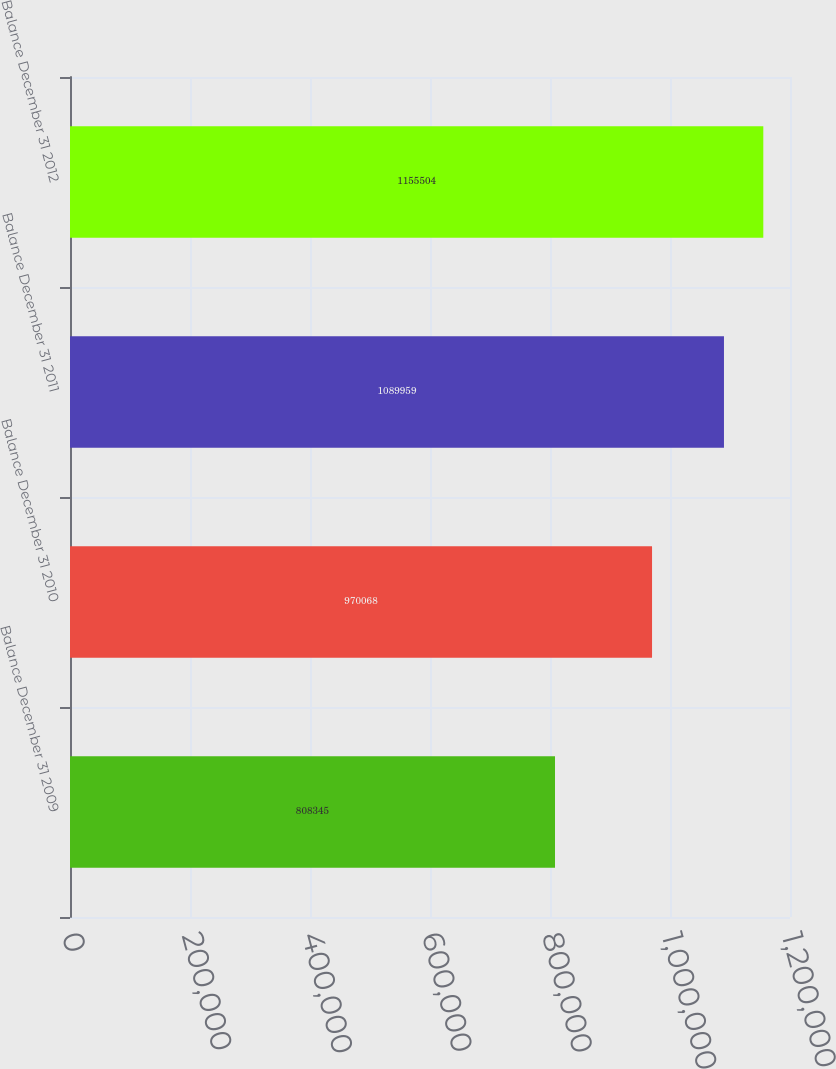Convert chart. <chart><loc_0><loc_0><loc_500><loc_500><bar_chart><fcel>Balance December 31 2009<fcel>Balance December 31 2010<fcel>Balance December 31 2011<fcel>Balance December 31 2012<nl><fcel>808345<fcel>970068<fcel>1.08996e+06<fcel>1.1555e+06<nl></chart> 